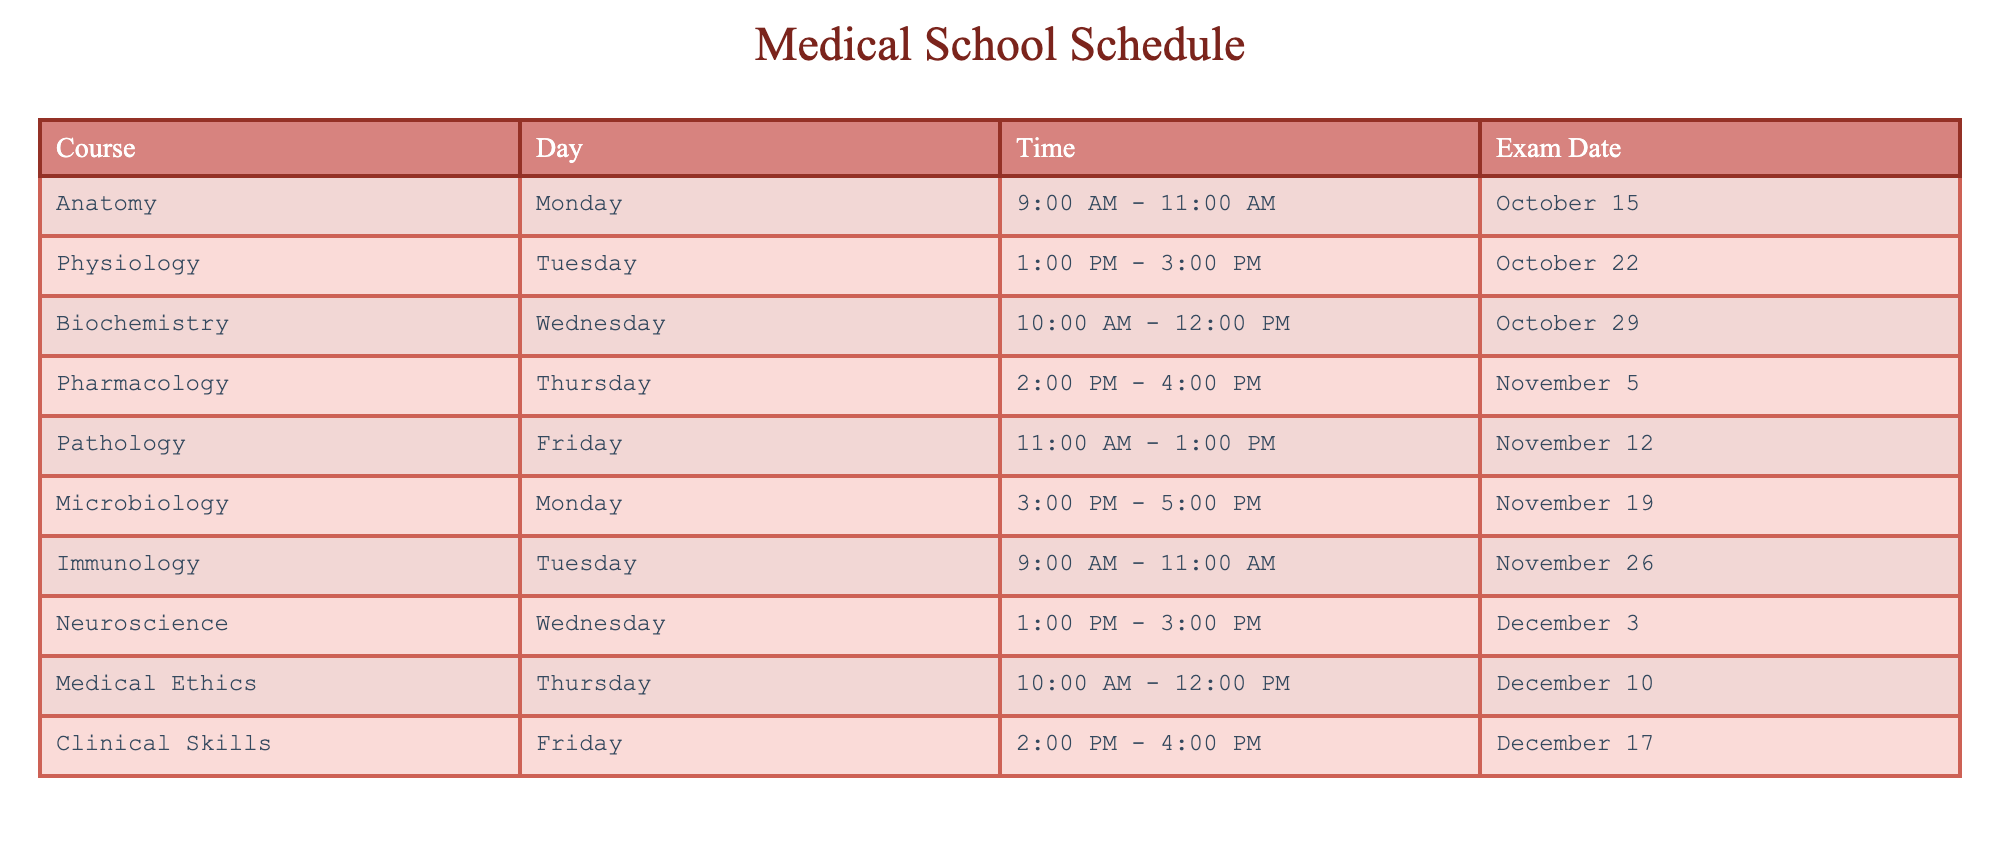What day is the Anatomy class scheduled for? Anatomy class is listed under the "Course" column in the table, and it shows that it is scheduled for "Monday".
Answer: Monday What time does the Pharmacology class take place? The "Time" column for Pharmacology shows "2:00 PM - 4:00 PM".
Answer: 2:00 PM - 4:00 PM Is there an exam for Physiology? The table indicates that Physiology has an exam scheduled on "October 22". Therefore, the answer is yes.
Answer: Yes How many classes are scheduled on Monday? Looking at the "Day" column, there are two classes listed on Monday: Anatomy and Microbiology. Therefore, the total is 2.
Answer: 2 What is the exam date for Neuroscience, and how does it compare to the Biochemistry exam date? Neuroscience exam date is "December 3" from the "Exam Date" column, while Biochemistry exam date is "October 29". December 3 is later than October 29.
Answer: December 3, later What class has its exam date immediately following the Immunology exam date? Immunology’s exam date is "November 26". The next exam date in the list is for Neuroscience on "December 3". This shows that Neuroscience follows Immunology's exam.
Answer: Neuroscience What is the average starting time of the classes scheduled in the table? The classes start at the following times: 9:00 AM, 1:00 PM, 10:00 AM, 2:00 PM, 11:00 AM, 3:00 PM, 9:00 AM, 1:00 PM, 10:00 AM, and 2:00 PM. First, convert these times to a 24-hour format, sum the hours (9 + 13 + 10 + 14 + 11 + 15 + 9 + 13 + 10 + 14 =  10.6), and divide by the number of classes (10): (10.6/10 = 10.6 = 10:36 AM).
Answer: 10:36 AM Is Medical Ethics scheduled after Microbiology? Checking the schedule, Medical Ethics is on Thursday with an exam date of "December 10" and Microbiology is on Monday, November 19. Since December 10 is after November 19, the answer is yes.
Answer: Yes 